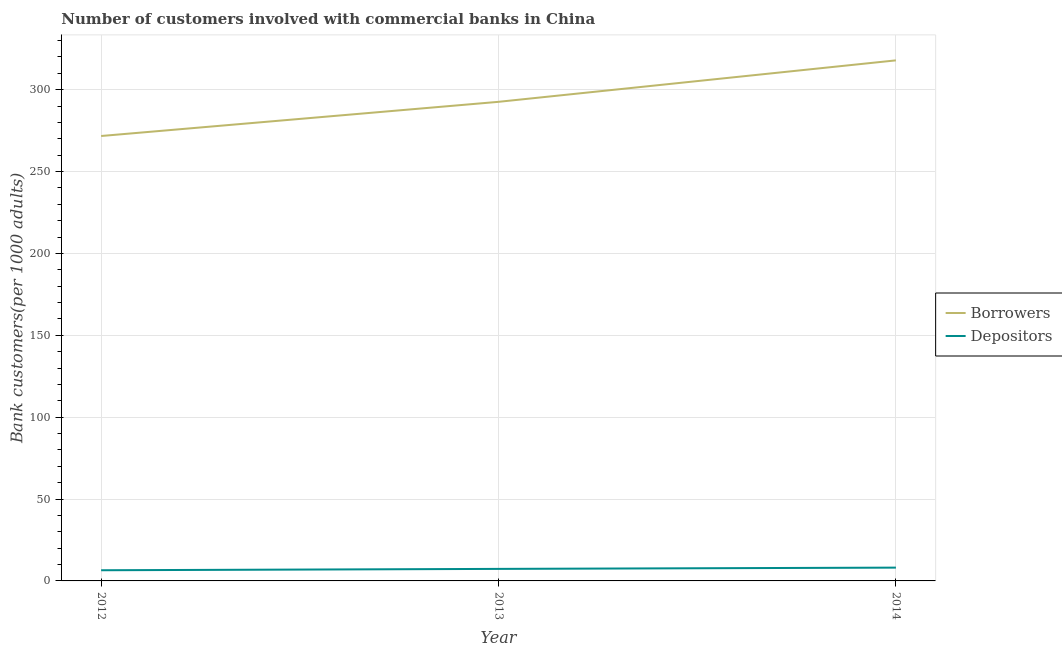How many different coloured lines are there?
Your answer should be very brief. 2. Does the line corresponding to number of depositors intersect with the line corresponding to number of borrowers?
Your answer should be compact. No. What is the number of borrowers in 2014?
Offer a very short reply. 317.9. Across all years, what is the maximum number of depositors?
Ensure brevity in your answer.  8.12. Across all years, what is the minimum number of borrowers?
Make the answer very short. 271.71. What is the total number of borrowers in the graph?
Give a very brief answer. 882.19. What is the difference between the number of depositors in 2013 and that in 2014?
Keep it short and to the point. -0.77. What is the difference between the number of borrowers in 2012 and the number of depositors in 2014?
Make the answer very short. 263.59. What is the average number of borrowers per year?
Offer a very short reply. 294.06. In the year 2013, what is the difference between the number of depositors and number of borrowers?
Your response must be concise. -285.23. In how many years, is the number of depositors greater than 50?
Ensure brevity in your answer.  0. What is the ratio of the number of depositors in 2012 to that in 2014?
Make the answer very short. 0.8. What is the difference between the highest and the second highest number of borrowers?
Make the answer very short. 25.32. What is the difference between the highest and the lowest number of depositors?
Give a very brief answer. 1.6. Is the number of depositors strictly greater than the number of borrowers over the years?
Provide a succinct answer. No. Is the number of depositors strictly less than the number of borrowers over the years?
Your answer should be compact. Yes. How many lines are there?
Make the answer very short. 2. How many years are there in the graph?
Offer a very short reply. 3. What is the difference between two consecutive major ticks on the Y-axis?
Ensure brevity in your answer.  50. Does the graph contain grids?
Keep it short and to the point. Yes. Where does the legend appear in the graph?
Make the answer very short. Center right. How are the legend labels stacked?
Offer a very short reply. Vertical. What is the title of the graph?
Ensure brevity in your answer.  Number of customers involved with commercial banks in China. Does "Methane emissions" appear as one of the legend labels in the graph?
Make the answer very short. No. What is the label or title of the X-axis?
Provide a short and direct response. Year. What is the label or title of the Y-axis?
Your answer should be compact. Bank customers(per 1000 adults). What is the Bank customers(per 1000 adults) in Borrowers in 2012?
Offer a terse response. 271.71. What is the Bank customers(per 1000 adults) in Depositors in 2012?
Your response must be concise. 6.52. What is the Bank customers(per 1000 adults) of Borrowers in 2013?
Offer a terse response. 292.58. What is the Bank customers(per 1000 adults) of Depositors in 2013?
Make the answer very short. 7.35. What is the Bank customers(per 1000 adults) in Borrowers in 2014?
Your answer should be very brief. 317.9. What is the Bank customers(per 1000 adults) of Depositors in 2014?
Keep it short and to the point. 8.12. Across all years, what is the maximum Bank customers(per 1000 adults) in Borrowers?
Offer a very short reply. 317.9. Across all years, what is the maximum Bank customers(per 1000 adults) of Depositors?
Offer a terse response. 8.12. Across all years, what is the minimum Bank customers(per 1000 adults) in Borrowers?
Make the answer very short. 271.71. Across all years, what is the minimum Bank customers(per 1000 adults) in Depositors?
Make the answer very short. 6.52. What is the total Bank customers(per 1000 adults) of Borrowers in the graph?
Provide a short and direct response. 882.19. What is the total Bank customers(per 1000 adults) in Depositors in the graph?
Make the answer very short. 21.99. What is the difference between the Bank customers(per 1000 adults) of Borrowers in 2012 and that in 2013?
Your answer should be very brief. -20.87. What is the difference between the Bank customers(per 1000 adults) of Depositors in 2012 and that in 2013?
Offer a terse response. -0.83. What is the difference between the Bank customers(per 1000 adults) in Borrowers in 2012 and that in 2014?
Your answer should be very brief. -46.19. What is the difference between the Bank customers(per 1000 adults) of Depositors in 2012 and that in 2014?
Provide a succinct answer. -1.6. What is the difference between the Bank customers(per 1000 adults) in Borrowers in 2013 and that in 2014?
Your answer should be very brief. -25.32. What is the difference between the Bank customers(per 1000 adults) in Depositors in 2013 and that in 2014?
Offer a terse response. -0.77. What is the difference between the Bank customers(per 1000 adults) of Borrowers in 2012 and the Bank customers(per 1000 adults) of Depositors in 2013?
Your answer should be compact. 264.36. What is the difference between the Bank customers(per 1000 adults) in Borrowers in 2012 and the Bank customers(per 1000 adults) in Depositors in 2014?
Provide a succinct answer. 263.59. What is the difference between the Bank customers(per 1000 adults) of Borrowers in 2013 and the Bank customers(per 1000 adults) of Depositors in 2014?
Ensure brevity in your answer.  284.46. What is the average Bank customers(per 1000 adults) in Borrowers per year?
Your response must be concise. 294.06. What is the average Bank customers(per 1000 adults) in Depositors per year?
Your answer should be very brief. 7.33. In the year 2012, what is the difference between the Bank customers(per 1000 adults) in Borrowers and Bank customers(per 1000 adults) in Depositors?
Keep it short and to the point. 265.19. In the year 2013, what is the difference between the Bank customers(per 1000 adults) in Borrowers and Bank customers(per 1000 adults) in Depositors?
Your answer should be very brief. 285.23. In the year 2014, what is the difference between the Bank customers(per 1000 adults) in Borrowers and Bank customers(per 1000 adults) in Depositors?
Offer a very short reply. 309.78. What is the ratio of the Bank customers(per 1000 adults) in Borrowers in 2012 to that in 2013?
Provide a short and direct response. 0.93. What is the ratio of the Bank customers(per 1000 adults) of Depositors in 2012 to that in 2013?
Give a very brief answer. 0.89. What is the ratio of the Bank customers(per 1000 adults) of Borrowers in 2012 to that in 2014?
Offer a terse response. 0.85. What is the ratio of the Bank customers(per 1000 adults) in Depositors in 2012 to that in 2014?
Offer a very short reply. 0.8. What is the ratio of the Bank customers(per 1000 adults) in Borrowers in 2013 to that in 2014?
Provide a succinct answer. 0.92. What is the ratio of the Bank customers(per 1000 adults) of Depositors in 2013 to that in 2014?
Your response must be concise. 0.91. What is the difference between the highest and the second highest Bank customers(per 1000 adults) of Borrowers?
Make the answer very short. 25.32. What is the difference between the highest and the second highest Bank customers(per 1000 adults) of Depositors?
Give a very brief answer. 0.77. What is the difference between the highest and the lowest Bank customers(per 1000 adults) of Borrowers?
Your answer should be compact. 46.19. What is the difference between the highest and the lowest Bank customers(per 1000 adults) of Depositors?
Offer a very short reply. 1.6. 